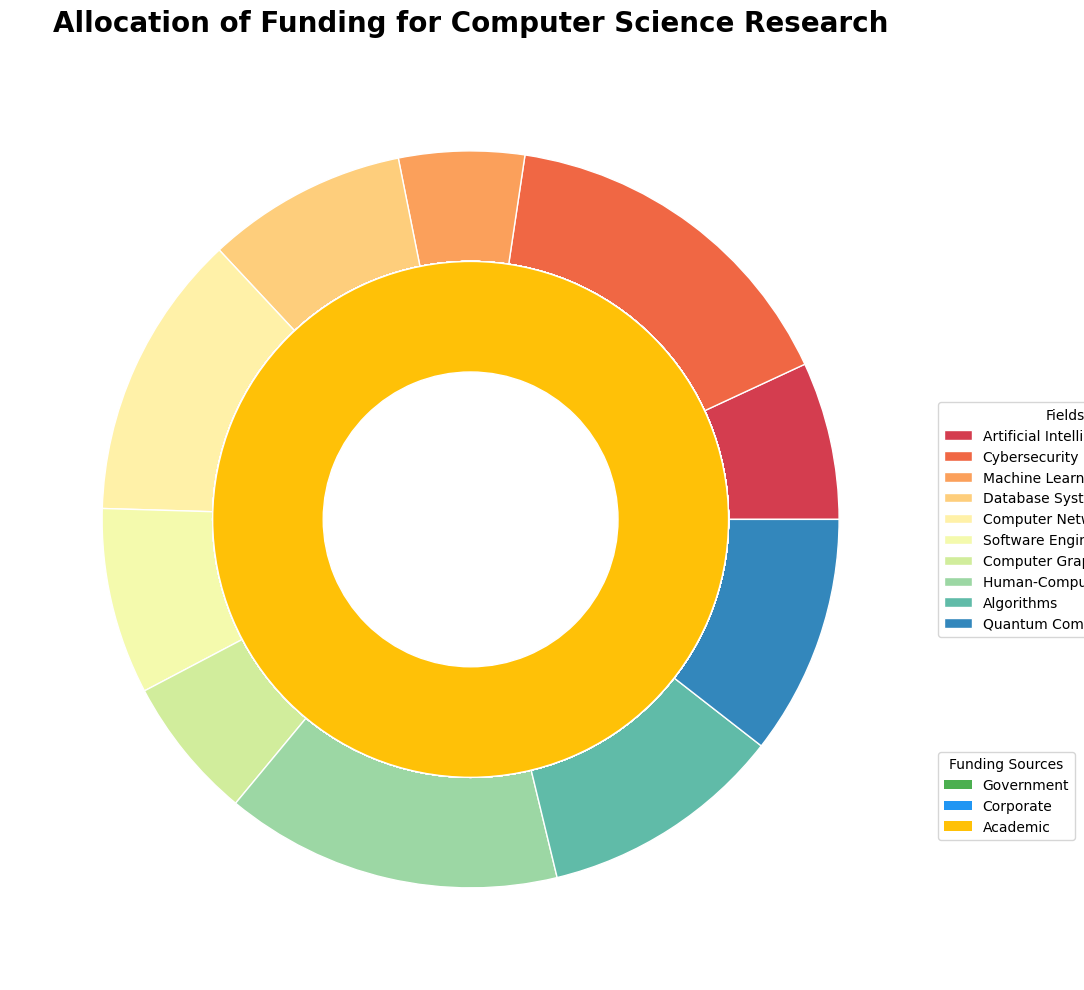What is the total amount of funding allocated to the field of Artificial Intelligence from all sources? Artificial Intelligence shows three funding sources: Government, Corporate, and Academic. Summing these values: 250,000,000 + 180,000,000 + 70,000,000. The total is 500,000,000
Answer: 500,000,000 Which funding source provides the most funding for Cybersecurity? In Cybersecurity, the funding amounts are: Government (200,000,000), Corporate (150,000,000), and Academic (50,000,000). The Government provides the most funding.
Answer: Government How does the funding for Machine Learning from Corporate sources compare to that from Government sources? For Machine Learning, the amounts are: Government (220,000,000) and Corporate (190,000,000). Corporate funding is 30,000,000 less than Government funding.
Answer: Government funding is higher Which field has the lowest amount of academic funding? By examining the Academic funding amounts: Artificial Intelligence (70,000,000), Cybersecurity (50,000,000), Machine Learning (60,000,000), Database Systems (40,000,000), Computer Networks (30,000,000), Software Engineering (45,000,000), Computer Graphics (25,000,000), Human-Computer Interaction (35,000,000), Algorithms (50,000,000), Quantum Computing (40,000,000), Computer Networks stands out with 30,000,000 as the lowest.
Answer: Computer Networks What is the combined funding from Corporate sources for Algorithms and Quantum Computing? The Corporate funding for Algorithms is 60,000,000 and for Quantum Computing is 120,000,000. Combined, they sum up to 180,000,000
Answer: 180,000,000 How does the funding for Software Engineering from Academic sources compare to that for Database Systems? The Academic funding amounts are: Software Engineering (45,000,000) and Database Systems (40,000,000). Software Engineering receives 5,000,000 more than Database Systems.
Answer: Software Engineering receives more Which fields receive more than 150,000,000 in total Government funding? The Government funding amounts are: Artificial Intelligence (250,000,000), Cybersecurity (200,000,000), Machine Learning (220,000,000), Database Systems (120,000,000), Computer Networks (140,000,000), Software Engineering (160,000,000), Computer Graphics (80,000,000), Human-Computer Interaction (90,000,000), Algorithms (110,000,000), Quantum Computing (180,000,000). Fields receiving more than 150,000,000 are: Artificial Intelligence, Cybersecurity, Machine Learning, Software Engineering, Quantum Computing.
Answer: Artificial Intelligence, Cybersecurity, Machine Learning, Software Engineering, Quantum Computing What is the total amount of funding for Human-Computer Interaction from all sources? Human-Computer Interaction receives funds from Government (90,000,000), Corporate (75,000,000), and Academic (35,000,000). The total is 90,000,000 + 75,000,000 + 35,000,000 which equals 200,000,000.
Answer: 200,000,000 How does the total funding for Database Systems compare to that for Computer Networks? Database Systems has total amounts: Government (120,000,000), Corporate (100,000,000), Academic (40,000,000) summing to 260,000,000. Computer Networks receives: Government (140,000,000), Corporate (110,000,000), Academic (30,000,000) summing to 280,000,000. Total funding for Computer Networks is 20,000,000 higher than for Database Systems.
Answer: Computer Networks receives more What proportion of total funding for Computer Science research is provided by Government sources? To find this, first calculate the total funding from Government across all fields, then the total funding from all sources. Sum of Government funding: 250,000,000 + 200,000,000 + 220,000,000 + 120,000,000 + 140,000,000 + 160,000,000 + 80,000,000 + 90,000,000 + 110,000,000 + 180,000,000 = 1,550,000,000. The total funding considering all sources and all fields is the sum of all values in the data: 4,930,000,000. The proportion is thus 1,550,000,000 / 4,930,000,000 ≈ 0.314 (or 31.4%).
Answer: 31.4% 